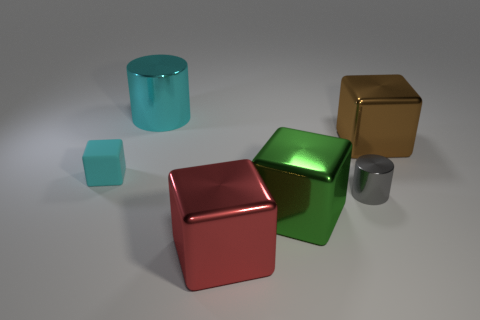What could be the purpose of arranging these objects like this? This arrangement seems to be a deliberate composition to showcase a variety of geometric shapes and textures. It might be used as a visual aid for educational purposes, explaining geometry, or as an artwork to appreciate the interplay of light, color, and form. Could this image be used in other fields? Absolutely, this image could be valuable for designers and 3D artists as inspiration or reference for understanding how different surfaces interact with light. It also might serve as a test image for calibrating monitor colors or for photographers practicing still life compositions. 